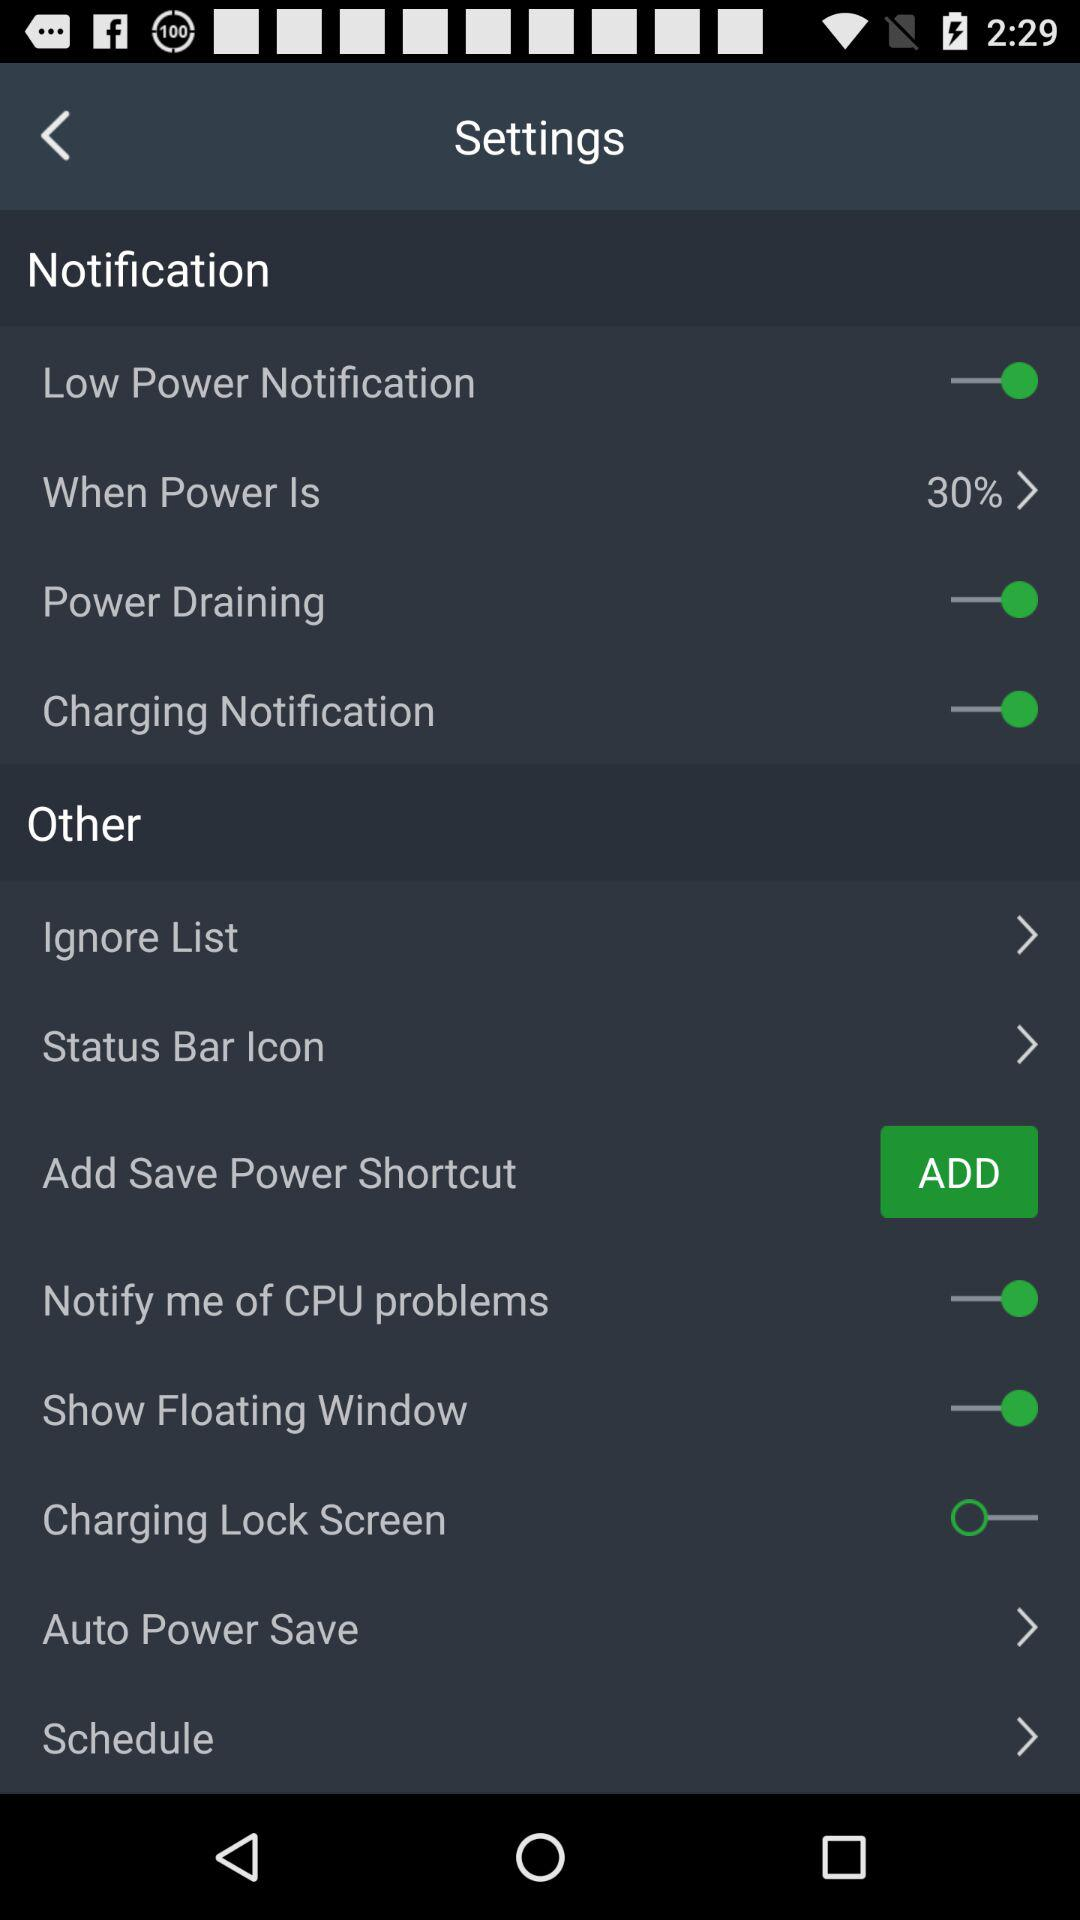What's the setting for "When Power Is"? The setting for "When Power Is" is 30%. 